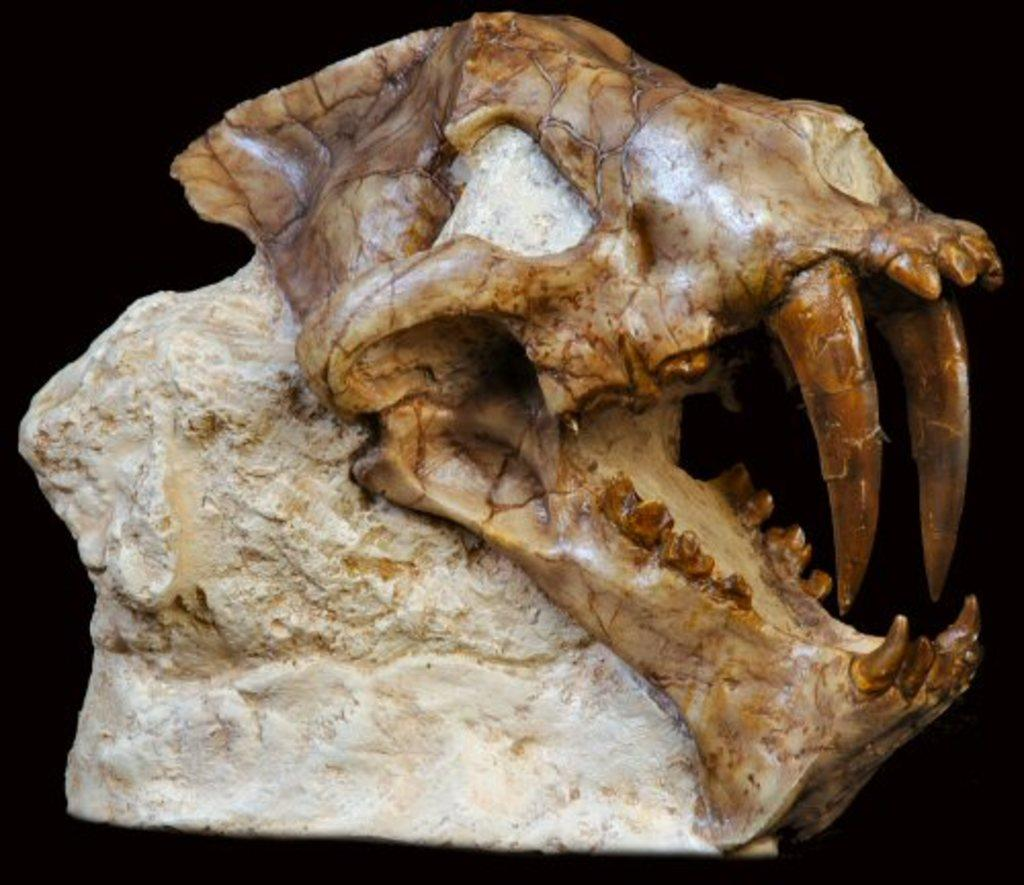What is the main subject of the picture? The main subject of the picture is a fossil of an animal. What can be observed about the background of the image? The background of the image is dark. Can you see a cow grazing in the background of the image? No, there is no cow or any indication of grazing in the image; it features a fossil of an animal with a dark background. 